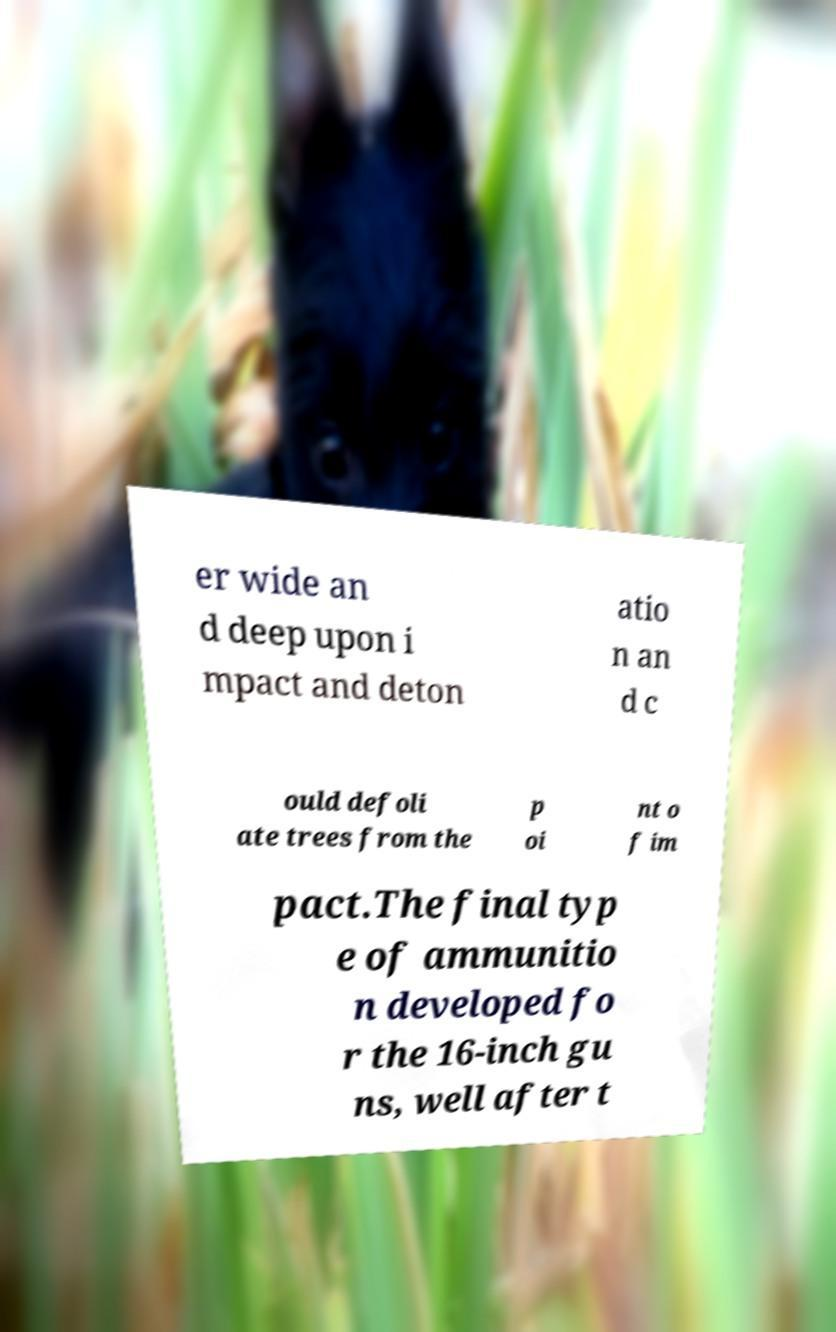Can you accurately transcribe the text from the provided image for me? er wide an d deep upon i mpact and deton atio n an d c ould defoli ate trees from the p oi nt o f im pact.The final typ e of ammunitio n developed fo r the 16-inch gu ns, well after t 